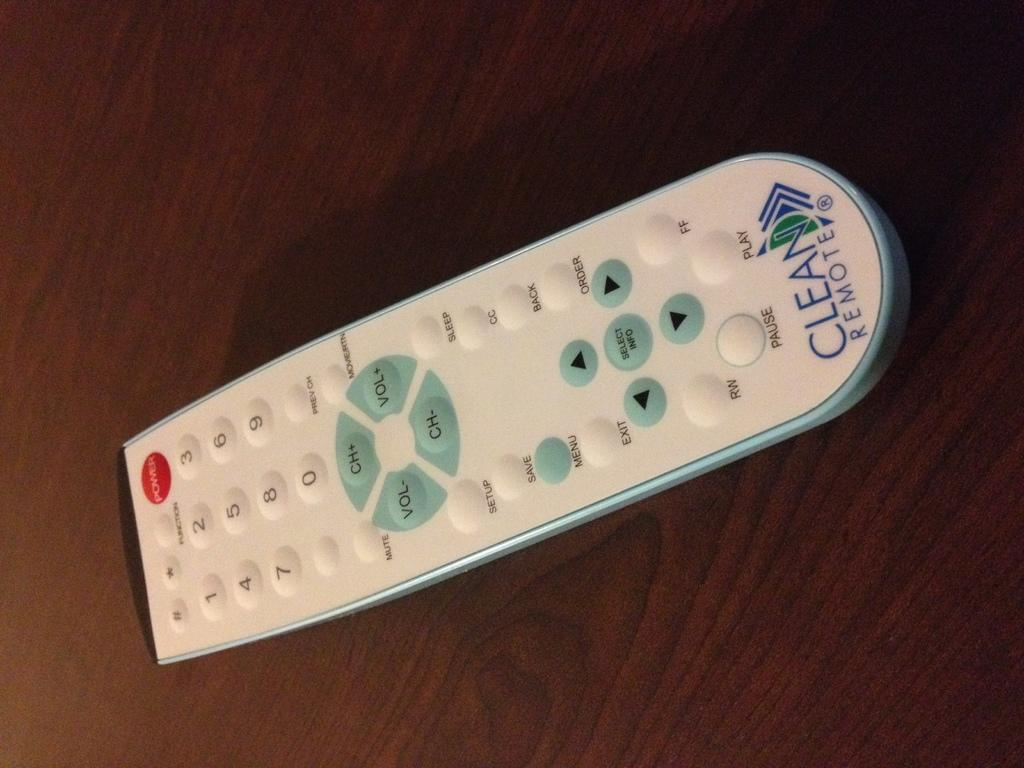<image>
Present a compact description of the photo's key features. A white remote that says Clean Remote on the bottom of it 